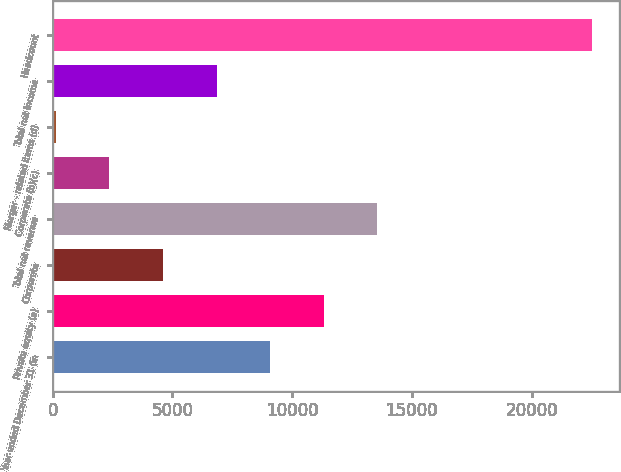Convert chart to OTSL. <chart><loc_0><loc_0><loc_500><loc_500><bar_chart><fcel>Year ended December 31 (in<fcel>Private equity (a)<fcel>Corporate<fcel>Total net revenue<fcel>Corporate (b)(c)<fcel>Merger - related items (d)<fcel>Total net income<fcel>Headcount<nl><fcel>9082.8<fcel>11321<fcel>4606.4<fcel>13559.2<fcel>2368.2<fcel>130<fcel>6844.6<fcel>22512<nl></chart> 